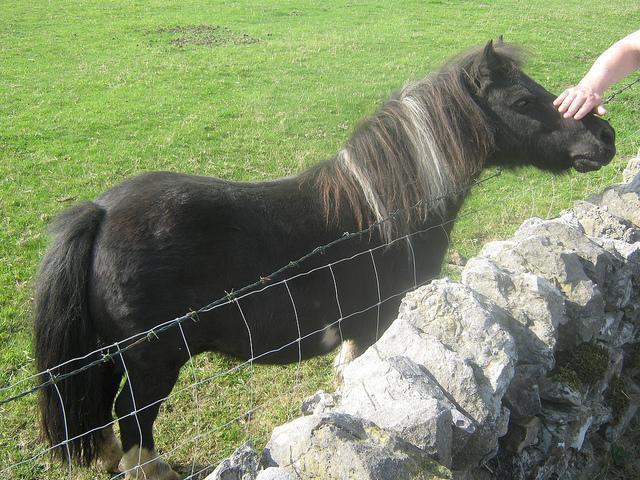Does the image validate the caption "The horse is below the person."?
Answer yes or no. No. 